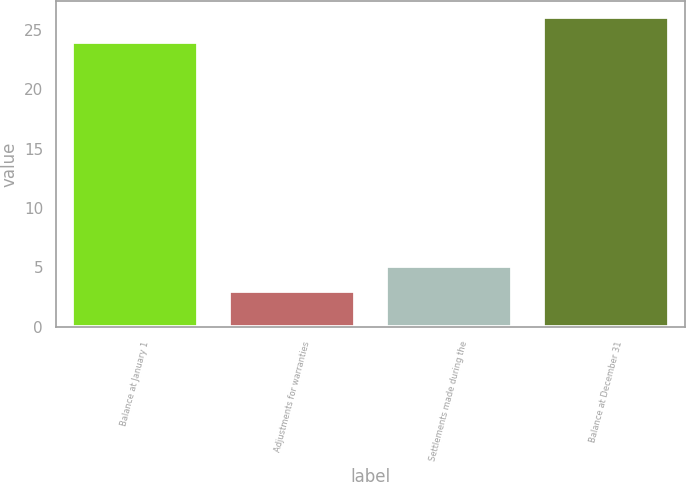Convert chart. <chart><loc_0><loc_0><loc_500><loc_500><bar_chart><fcel>Balance at January 1<fcel>Adjustments for warranties<fcel>Settlements made during the<fcel>Balance at December 31<nl><fcel>24<fcel>3<fcel>5.1<fcel>26.1<nl></chart> 